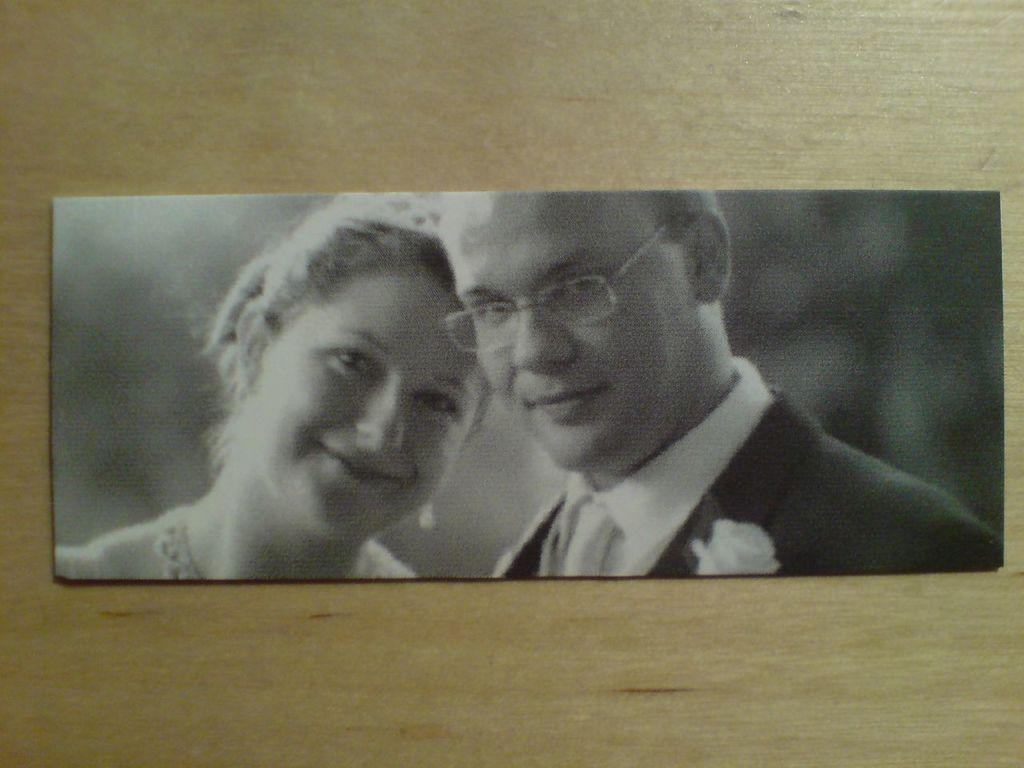What is the main object on the wooden surface in the image? There is a photo on a wooden surface in the image. What can be seen in the photo? The photo contains two people. What type of stamp is visible on the photo? There is no stamp visible on the photo; it only contains an image of two people. 